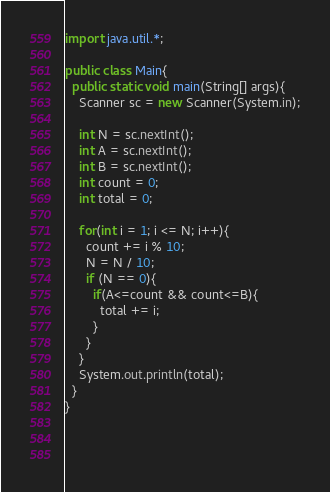Convert code to text. <code><loc_0><loc_0><loc_500><loc_500><_Java_>import java.util.*;

public class Main{
  public static void main(String[] args){
    Scanner sc = new Scanner(System.in);
    
    int N = sc.nextInt();
    int A = sc.nextInt();
    int B = sc.nextInt();
    int count = 0;
    int total = 0;
    
    for(int i = 1; i <= N; i++){
      count += i % 10;
      N = N / 10;
      if (N == 0){
        if(A<=count && count<=B){
          total += i;
        }
      }
    }
    System.out.println(total);
  }
}

       
      </code> 